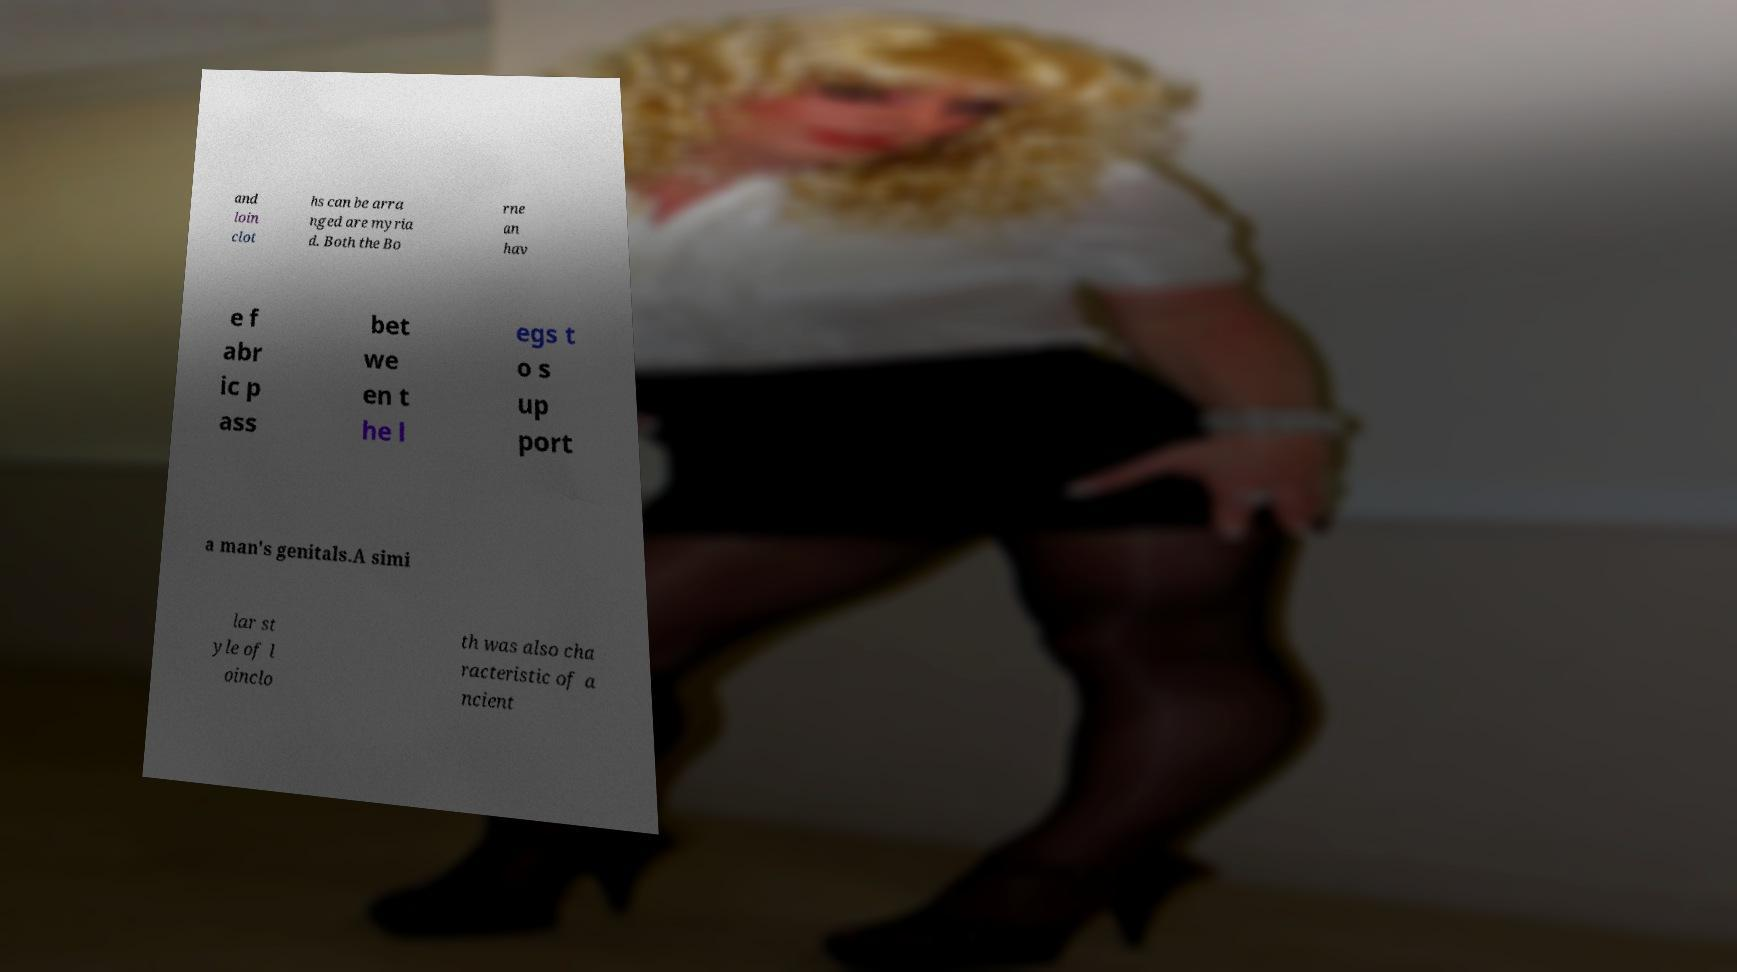Please read and relay the text visible in this image. What does it say? and loin clot hs can be arra nged are myria d. Both the Bo rne an hav e f abr ic p ass bet we en t he l egs t o s up port a man's genitals.A simi lar st yle of l oinclo th was also cha racteristic of a ncient 